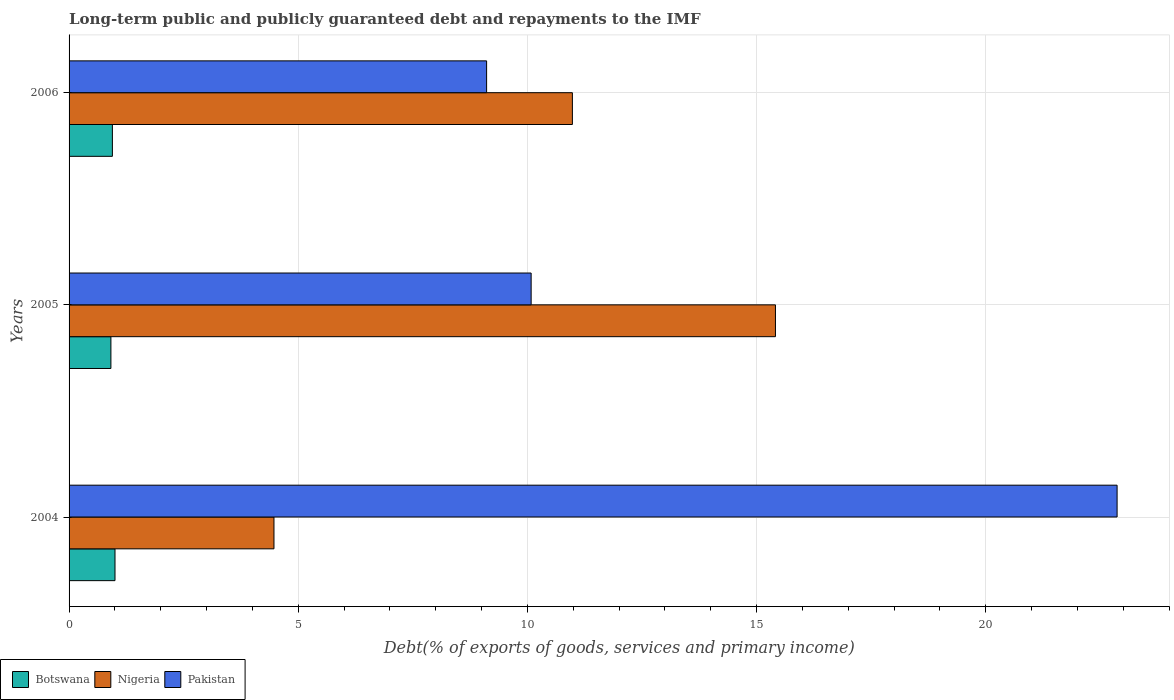How many groups of bars are there?
Provide a short and direct response. 3. Are the number of bars per tick equal to the number of legend labels?
Give a very brief answer. Yes. Are the number of bars on each tick of the Y-axis equal?
Your answer should be very brief. Yes. What is the label of the 2nd group of bars from the top?
Make the answer very short. 2005. In how many cases, is the number of bars for a given year not equal to the number of legend labels?
Provide a succinct answer. 0. What is the debt and repayments in Botswana in 2005?
Give a very brief answer. 0.91. Across all years, what is the maximum debt and repayments in Botswana?
Your response must be concise. 1. Across all years, what is the minimum debt and repayments in Pakistan?
Your answer should be very brief. 9.11. In which year was the debt and repayments in Pakistan maximum?
Make the answer very short. 2004. In which year was the debt and repayments in Pakistan minimum?
Provide a short and direct response. 2006. What is the total debt and repayments in Botswana in the graph?
Provide a short and direct response. 2.86. What is the difference between the debt and repayments in Nigeria in 2005 and that in 2006?
Give a very brief answer. 4.43. What is the difference between the debt and repayments in Nigeria in 2004 and the debt and repayments in Botswana in 2006?
Your answer should be compact. 3.53. What is the average debt and repayments in Pakistan per year?
Offer a terse response. 14.02. In the year 2006, what is the difference between the debt and repayments in Nigeria and debt and repayments in Botswana?
Make the answer very short. 10.04. In how many years, is the debt and repayments in Nigeria greater than 15 %?
Keep it short and to the point. 1. What is the ratio of the debt and repayments in Nigeria in 2004 to that in 2006?
Provide a succinct answer. 0.41. Is the debt and repayments in Nigeria in 2005 less than that in 2006?
Provide a succinct answer. No. What is the difference between the highest and the second highest debt and repayments in Pakistan?
Provide a succinct answer. 12.78. What is the difference between the highest and the lowest debt and repayments in Pakistan?
Ensure brevity in your answer.  13.75. What does the 2nd bar from the top in 2005 represents?
Keep it short and to the point. Nigeria. Is it the case that in every year, the sum of the debt and repayments in Botswana and debt and repayments in Pakistan is greater than the debt and repayments in Nigeria?
Give a very brief answer. No. Are all the bars in the graph horizontal?
Offer a terse response. Yes. How many years are there in the graph?
Your answer should be compact. 3. What is the difference between two consecutive major ticks on the X-axis?
Your response must be concise. 5. Are the values on the major ticks of X-axis written in scientific E-notation?
Your answer should be compact. No. Does the graph contain any zero values?
Your response must be concise. No. Does the graph contain grids?
Keep it short and to the point. Yes. What is the title of the graph?
Your answer should be compact. Long-term public and publicly guaranteed debt and repayments to the IMF. Does "Guyana" appear as one of the legend labels in the graph?
Provide a short and direct response. No. What is the label or title of the X-axis?
Give a very brief answer. Debt(% of exports of goods, services and primary income). What is the label or title of the Y-axis?
Your answer should be compact. Years. What is the Debt(% of exports of goods, services and primary income) of Botswana in 2004?
Give a very brief answer. 1. What is the Debt(% of exports of goods, services and primary income) in Nigeria in 2004?
Offer a very short reply. 4.47. What is the Debt(% of exports of goods, services and primary income) in Pakistan in 2004?
Provide a succinct answer. 22.86. What is the Debt(% of exports of goods, services and primary income) of Botswana in 2005?
Make the answer very short. 0.91. What is the Debt(% of exports of goods, services and primary income) of Nigeria in 2005?
Provide a short and direct response. 15.41. What is the Debt(% of exports of goods, services and primary income) of Pakistan in 2005?
Keep it short and to the point. 10.08. What is the Debt(% of exports of goods, services and primary income) of Botswana in 2006?
Your answer should be very brief. 0.95. What is the Debt(% of exports of goods, services and primary income) in Nigeria in 2006?
Make the answer very short. 10.98. What is the Debt(% of exports of goods, services and primary income) of Pakistan in 2006?
Keep it short and to the point. 9.11. Across all years, what is the maximum Debt(% of exports of goods, services and primary income) in Botswana?
Provide a succinct answer. 1. Across all years, what is the maximum Debt(% of exports of goods, services and primary income) of Nigeria?
Keep it short and to the point. 15.41. Across all years, what is the maximum Debt(% of exports of goods, services and primary income) of Pakistan?
Provide a short and direct response. 22.86. Across all years, what is the minimum Debt(% of exports of goods, services and primary income) in Botswana?
Ensure brevity in your answer.  0.91. Across all years, what is the minimum Debt(% of exports of goods, services and primary income) in Nigeria?
Provide a succinct answer. 4.47. Across all years, what is the minimum Debt(% of exports of goods, services and primary income) in Pakistan?
Your response must be concise. 9.11. What is the total Debt(% of exports of goods, services and primary income) in Botswana in the graph?
Offer a very short reply. 2.86. What is the total Debt(% of exports of goods, services and primary income) in Nigeria in the graph?
Provide a succinct answer. 30.86. What is the total Debt(% of exports of goods, services and primary income) of Pakistan in the graph?
Your response must be concise. 42.05. What is the difference between the Debt(% of exports of goods, services and primary income) in Botswana in 2004 and that in 2005?
Provide a succinct answer. 0.09. What is the difference between the Debt(% of exports of goods, services and primary income) of Nigeria in 2004 and that in 2005?
Your answer should be very brief. -10.94. What is the difference between the Debt(% of exports of goods, services and primary income) of Pakistan in 2004 and that in 2005?
Make the answer very short. 12.78. What is the difference between the Debt(% of exports of goods, services and primary income) in Botswana in 2004 and that in 2006?
Offer a very short reply. 0.06. What is the difference between the Debt(% of exports of goods, services and primary income) in Nigeria in 2004 and that in 2006?
Provide a succinct answer. -6.51. What is the difference between the Debt(% of exports of goods, services and primary income) of Pakistan in 2004 and that in 2006?
Your answer should be compact. 13.76. What is the difference between the Debt(% of exports of goods, services and primary income) in Botswana in 2005 and that in 2006?
Give a very brief answer. -0.03. What is the difference between the Debt(% of exports of goods, services and primary income) of Nigeria in 2005 and that in 2006?
Your answer should be compact. 4.43. What is the difference between the Debt(% of exports of goods, services and primary income) in Pakistan in 2005 and that in 2006?
Ensure brevity in your answer.  0.97. What is the difference between the Debt(% of exports of goods, services and primary income) in Botswana in 2004 and the Debt(% of exports of goods, services and primary income) in Nigeria in 2005?
Provide a succinct answer. -14.41. What is the difference between the Debt(% of exports of goods, services and primary income) of Botswana in 2004 and the Debt(% of exports of goods, services and primary income) of Pakistan in 2005?
Offer a very short reply. -9.08. What is the difference between the Debt(% of exports of goods, services and primary income) of Nigeria in 2004 and the Debt(% of exports of goods, services and primary income) of Pakistan in 2005?
Keep it short and to the point. -5.61. What is the difference between the Debt(% of exports of goods, services and primary income) in Botswana in 2004 and the Debt(% of exports of goods, services and primary income) in Nigeria in 2006?
Offer a terse response. -9.98. What is the difference between the Debt(% of exports of goods, services and primary income) in Botswana in 2004 and the Debt(% of exports of goods, services and primary income) in Pakistan in 2006?
Ensure brevity in your answer.  -8.11. What is the difference between the Debt(% of exports of goods, services and primary income) in Nigeria in 2004 and the Debt(% of exports of goods, services and primary income) in Pakistan in 2006?
Keep it short and to the point. -4.64. What is the difference between the Debt(% of exports of goods, services and primary income) in Botswana in 2005 and the Debt(% of exports of goods, services and primary income) in Nigeria in 2006?
Give a very brief answer. -10.07. What is the difference between the Debt(% of exports of goods, services and primary income) of Botswana in 2005 and the Debt(% of exports of goods, services and primary income) of Pakistan in 2006?
Provide a short and direct response. -8.2. What is the difference between the Debt(% of exports of goods, services and primary income) in Nigeria in 2005 and the Debt(% of exports of goods, services and primary income) in Pakistan in 2006?
Offer a very short reply. 6.3. What is the average Debt(% of exports of goods, services and primary income) of Botswana per year?
Offer a terse response. 0.95. What is the average Debt(% of exports of goods, services and primary income) in Nigeria per year?
Your response must be concise. 10.29. What is the average Debt(% of exports of goods, services and primary income) of Pakistan per year?
Offer a terse response. 14.02. In the year 2004, what is the difference between the Debt(% of exports of goods, services and primary income) of Botswana and Debt(% of exports of goods, services and primary income) of Nigeria?
Keep it short and to the point. -3.47. In the year 2004, what is the difference between the Debt(% of exports of goods, services and primary income) of Botswana and Debt(% of exports of goods, services and primary income) of Pakistan?
Provide a succinct answer. -21.86. In the year 2004, what is the difference between the Debt(% of exports of goods, services and primary income) of Nigeria and Debt(% of exports of goods, services and primary income) of Pakistan?
Provide a short and direct response. -18.39. In the year 2005, what is the difference between the Debt(% of exports of goods, services and primary income) of Botswana and Debt(% of exports of goods, services and primary income) of Nigeria?
Offer a terse response. -14.5. In the year 2005, what is the difference between the Debt(% of exports of goods, services and primary income) of Botswana and Debt(% of exports of goods, services and primary income) of Pakistan?
Keep it short and to the point. -9.17. In the year 2005, what is the difference between the Debt(% of exports of goods, services and primary income) in Nigeria and Debt(% of exports of goods, services and primary income) in Pakistan?
Your response must be concise. 5.33. In the year 2006, what is the difference between the Debt(% of exports of goods, services and primary income) of Botswana and Debt(% of exports of goods, services and primary income) of Nigeria?
Your answer should be compact. -10.04. In the year 2006, what is the difference between the Debt(% of exports of goods, services and primary income) in Botswana and Debt(% of exports of goods, services and primary income) in Pakistan?
Offer a terse response. -8.16. In the year 2006, what is the difference between the Debt(% of exports of goods, services and primary income) in Nigeria and Debt(% of exports of goods, services and primary income) in Pakistan?
Keep it short and to the point. 1.87. What is the ratio of the Debt(% of exports of goods, services and primary income) in Botswana in 2004 to that in 2005?
Offer a terse response. 1.1. What is the ratio of the Debt(% of exports of goods, services and primary income) of Nigeria in 2004 to that in 2005?
Offer a terse response. 0.29. What is the ratio of the Debt(% of exports of goods, services and primary income) of Pakistan in 2004 to that in 2005?
Provide a succinct answer. 2.27. What is the ratio of the Debt(% of exports of goods, services and primary income) of Botswana in 2004 to that in 2006?
Offer a terse response. 1.06. What is the ratio of the Debt(% of exports of goods, services and primary income) in Nigeria in 2004 to that in 2006?
Provide a succinct answer. 0.41. What is the ratio of the Debt(% of exports of goods, services and primary income) in Pakistan in 2004 to that in 2006?
Ensure brevity in your answer.  2.51. What is the ratio of the Debt(% of exports of goods, services and primary income) in Botswana in 2005 to that in 2006?
Your answer should be very brief. 0.97. What is the ratio of the Debt(% of exports of goods, services and primary income) in Nigeria in 2005 to that in 2006?
Ensure brevity in your answer.  1.4. What is the ratio of the Debt(% of exports of goods, services and primary income) in Pakistan in 2005 to that in 2006?
Keep it short and to the point. 1.11. What is the difference between the highest and the second highest Debt(% of exports of goods, services and primary income) of Botswana?
Offer a terse response. 0.06. What is the difference between the highest and the second highest Debt(% of exports of goods, services and primary income) of Nigeria?
Your answer should be very brief. 4.43. What is the difference between the highest and the second highest Debt(% of exports of goods, services and primary income) of Pakistan?
Make the answer very short. 12.78. What is the difference between the highest and the lowest Debt(% of exports of goods, services and primary income) of Botswana?
Your response must be concise. 0.09. What is the difference between the highest and the lowest Debt(% of exports of goods, services and primary income) in Nigeria?
Your answer should be compact. 10.94. What is the difference between the highest and the lowest Debt(% of exports of goods, services and primary income) in Pakistan?
Provide a succinct answer. 13.76. 